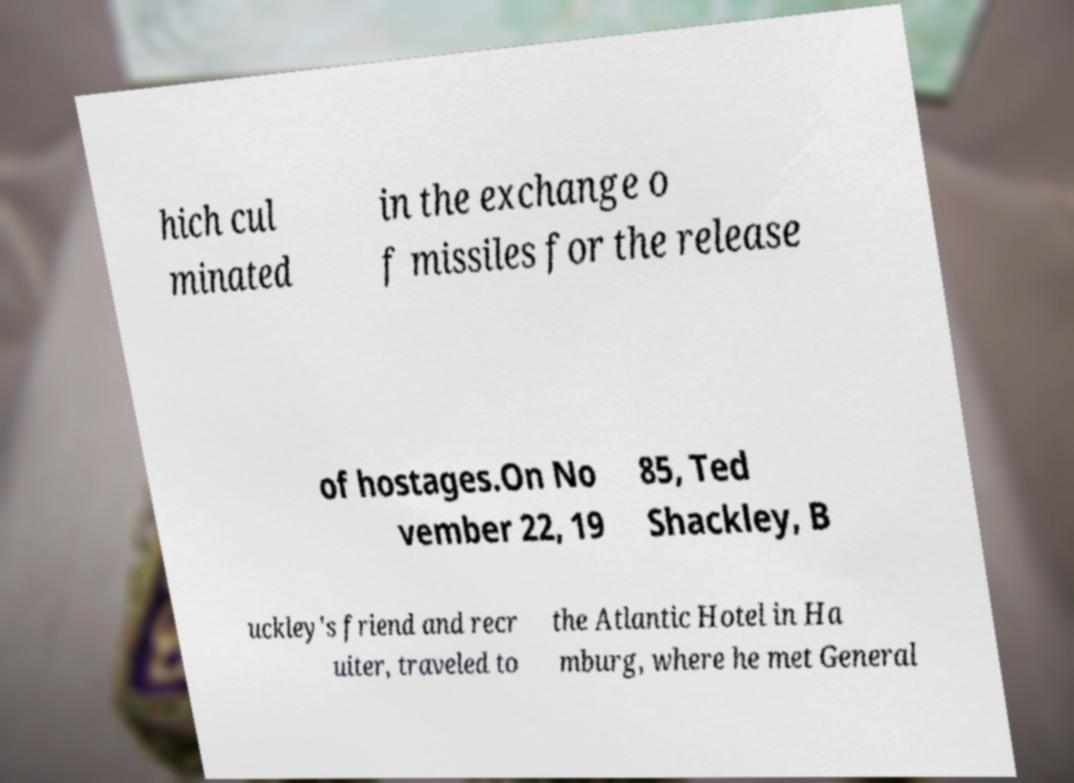There's text embedded in this image that I need extracted. Can you transcribe it verbatim? hich cul minated in the exchange o f missiles for the release of hostages.On No vember 22, 19 85, Ted Shackley, B uckley's friend and recr uiter, traveled to the Atlantic Hotel in Ha mburg, where he met General 